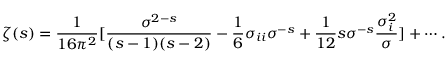<formula> <loc_0><loc_0><loc_500><loc_500>\zeta ( s ) = { \frac { 1 } { 1 6 \pi ^ { 2 } } } [ { \frac { \sigma ^ { 2 - s } } { ( s - 1 ) ( s - 2 ) } } - { \frac { 1 } { 6 } } \sigma _ { i i } \sigma ^ { - s } + { \frac { 1 } { 1 2 } } s \sigma ^ { - s } { \frac { \sigma _ { i } ^ { 2 } } { \sigma } } ] + \cdots .</formula> 